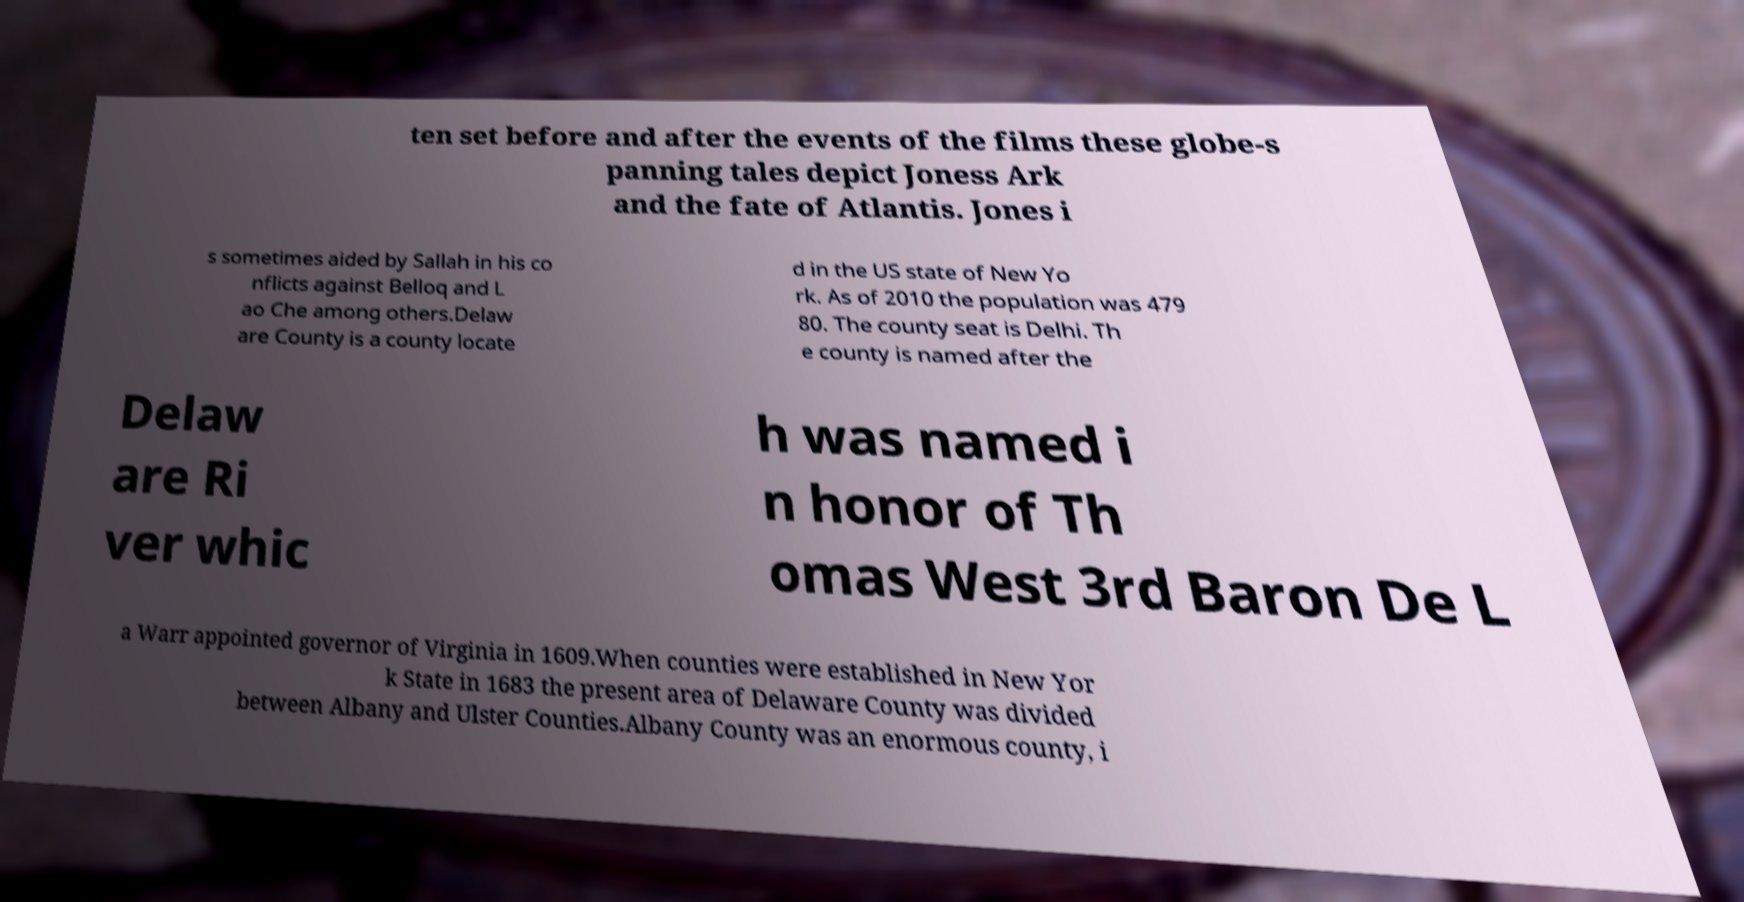There's text embedded in this image that I need extracted. Can you transcribe it verbatim? ten set before and after the events of the films these globe-s panning tales depict Joness Ark and the fate of Atlantis. Jones i s sometimes aided by Sallah in his co nflicts against Belloq and L ao Che among others.Delaw are County is a county locate d in the US state of New Yo rk. As of 2010 the population was 479 80. The county seat is Delhi. Th e county is named after the Delaw are Ri ver whic h was named i n honor of Th omas West 3rd Baron De L a Warr appointed governor of Virginia in 1609.When counties were established in New Yor k State in 1683 the present area of Delaware County was divided between Albany and Ulster Counties.Albany County was an enormous county, i 